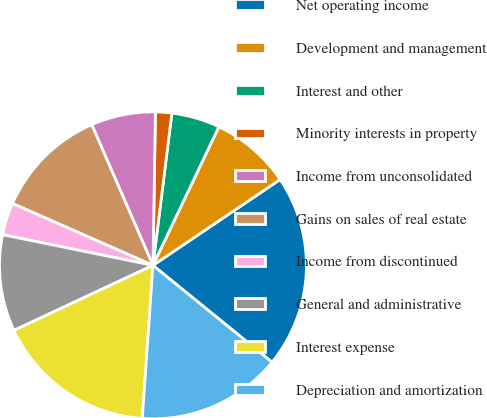<chart> <loc_0><loc_0><loc_500><loc_500><pie_chart><fcel>Net operating income<fcel>Development and management<fcel>Interest and other<fcel>Minority interests in property<fcel>Income from unconsolidated<fcel>Gains on sales of real estate<fcel>Income from discontinued<fcel>General and administrative<fcel>Interest expense<fcel>Depreciation and amortization<nl><fcel>20.32%<fcel>8.48%<fcel>5.1%<fcel>1.71%<fcel>6.79%<fcel>11.86%<fcel>3.4%<fcel>10.17%<fcel>16.93%<fcel>15.24%<nl></chart> 